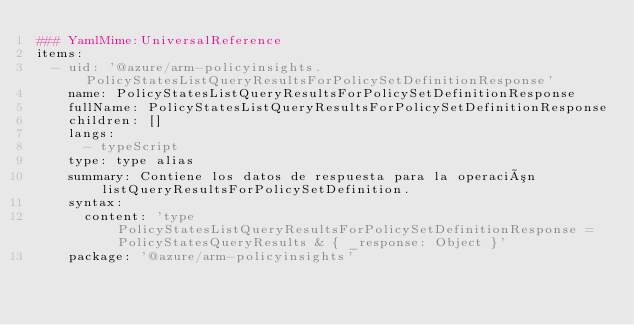Convert code to text. <code><loc_0><loc_0><loc_500><loc_500><_YAML_>### YamlMime:UniversalReference
items:
  - uid: '@azure/arm-policyinsights.PolicyStatesListQueryResultsForPolicySetDefinitionResponse'
    name: PolicyStatesListQueryResultsForPolicySetDefinitionResponse
    fullName: PolicyStatesListQueryResultsForPolicySetDefinitionResponse
    children: []
    langs:
      - typeScript
    type: type alias
    summary: Contiene los datos de respuesta para la operación listQueryResultsForPolicySetDefinition.
    syntax:
      content: 'type PolicyStatesListQueryResultsForPolicySetDefinitionResponse = PolicyStatesQueryResults & { _response: Object }'
    package: '@azure/arm-policyinsights'</code> 